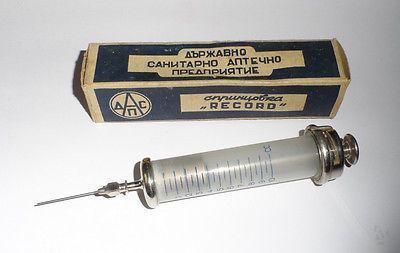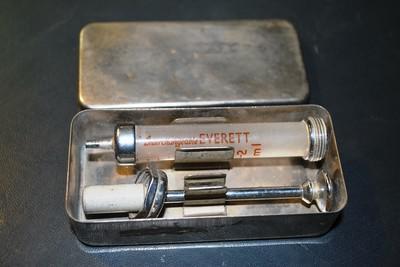The first image is the image on the left, the second image is the image on the right. Considering the images on both sides, is "there are at least 3 syringes" valid? Answer yes or no. No. The first image is the image on the left, the second image is the image on the right. Examine the images to the left and right. Is the description "There are no more than two syringes in total." accurate? Answer yes or no. Yes. 